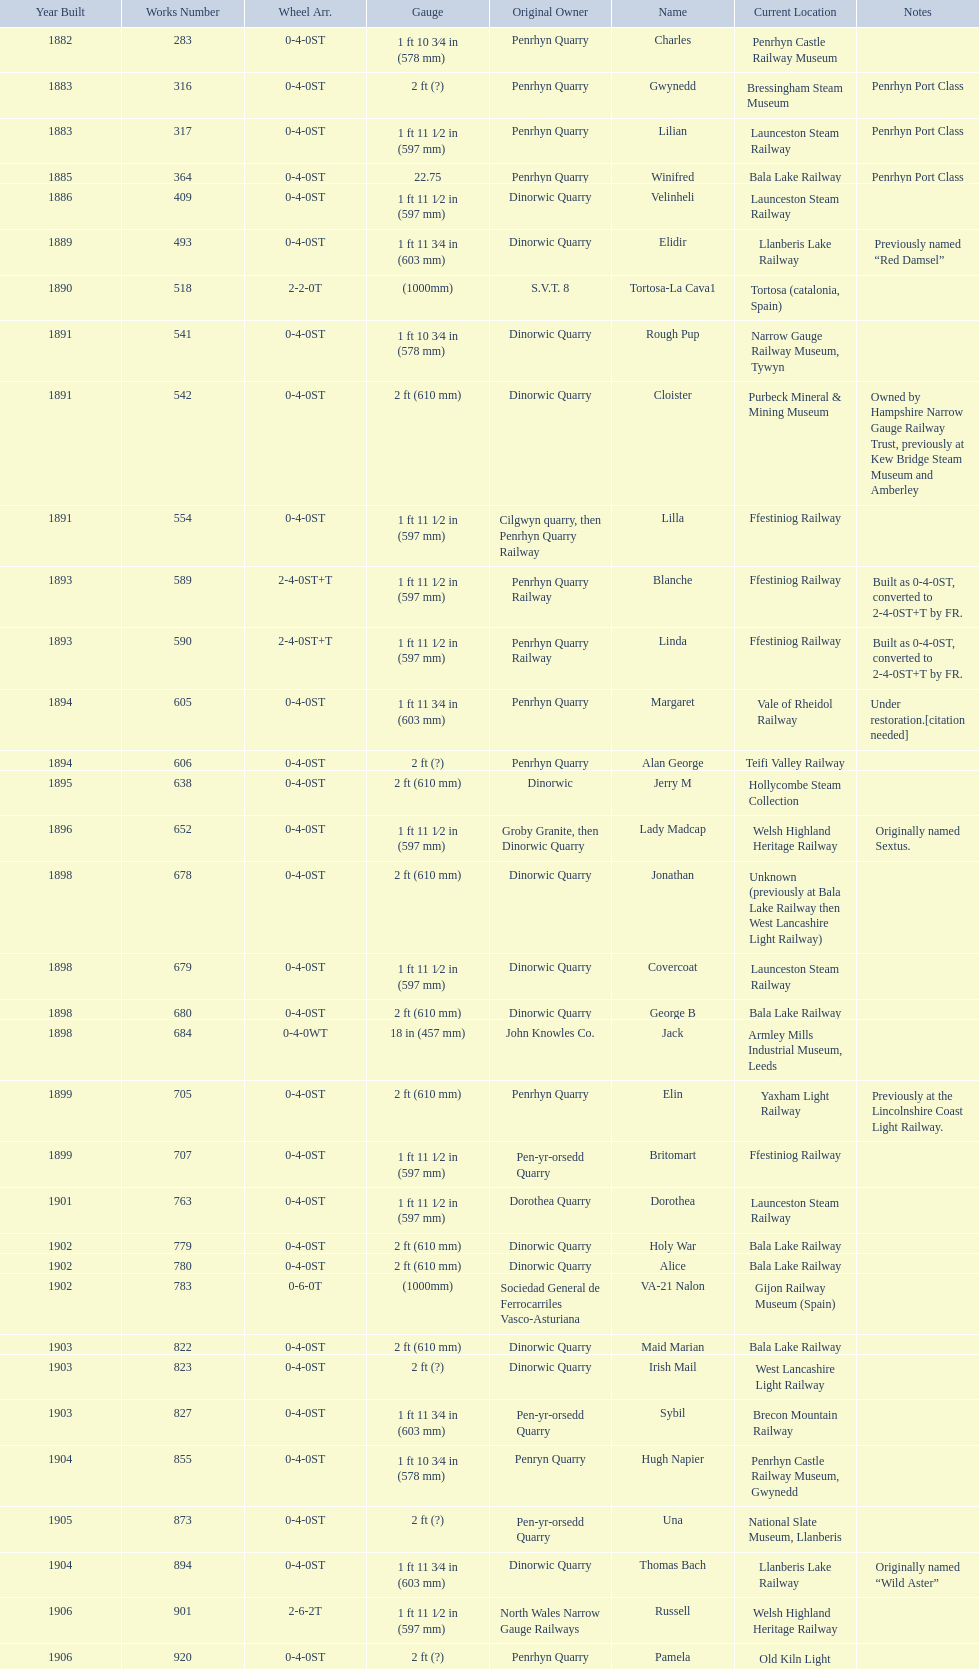What is the works number of the only item built in 1882? 283. 